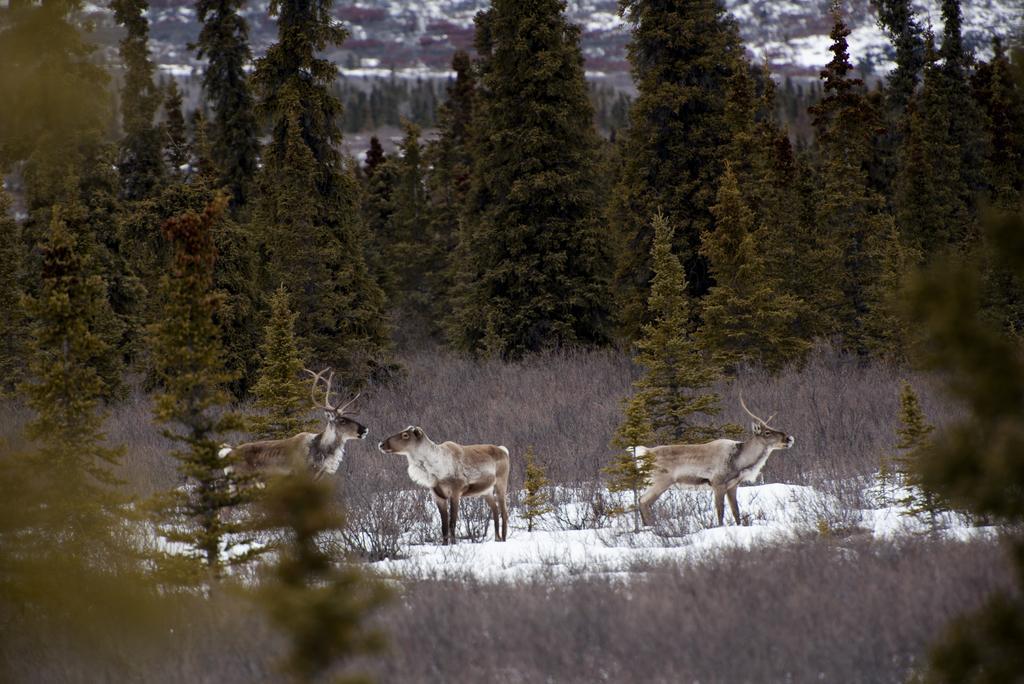Could you give a brief overview of what you see in this image? In this image we can see three animals on the ground, some snow on the ground near the animals, some trees and grass on the ground. There are some white objects on the ground looks like snow on the top of the image. 